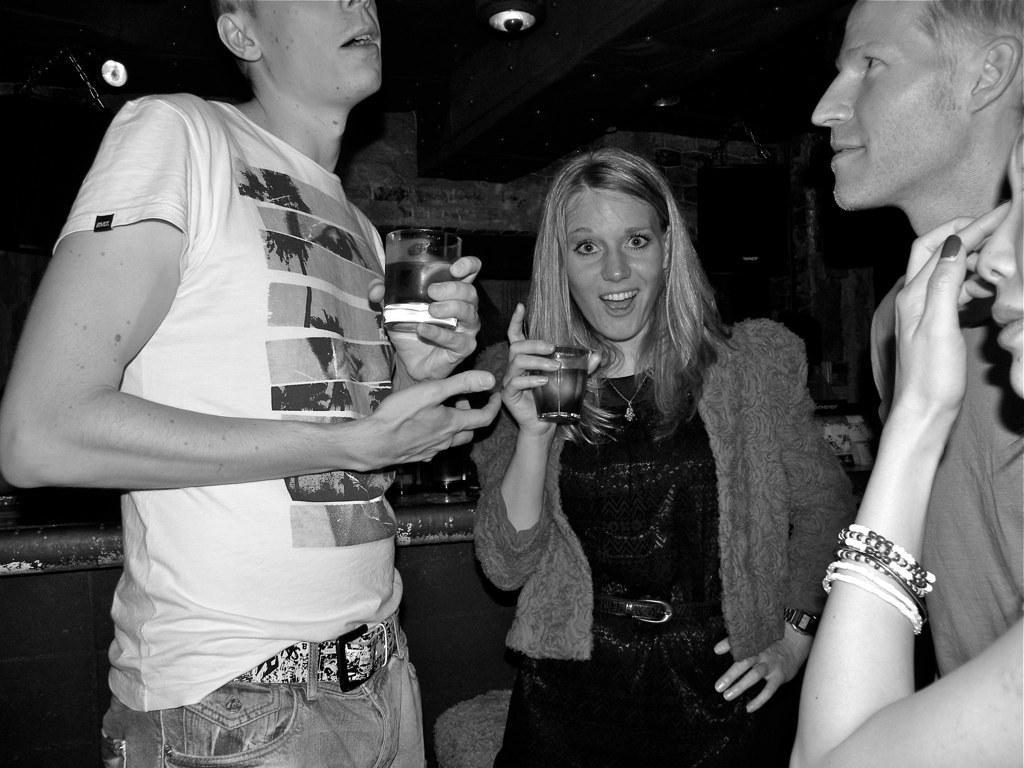Can you describe this image briefly? In the image we can see the black and white picture of two men and two women wearing clothes. The left side man and woman are holding a glass in their hands. Here we can see lights and the right side woman is wearing the bracelet, and the background is dark. 